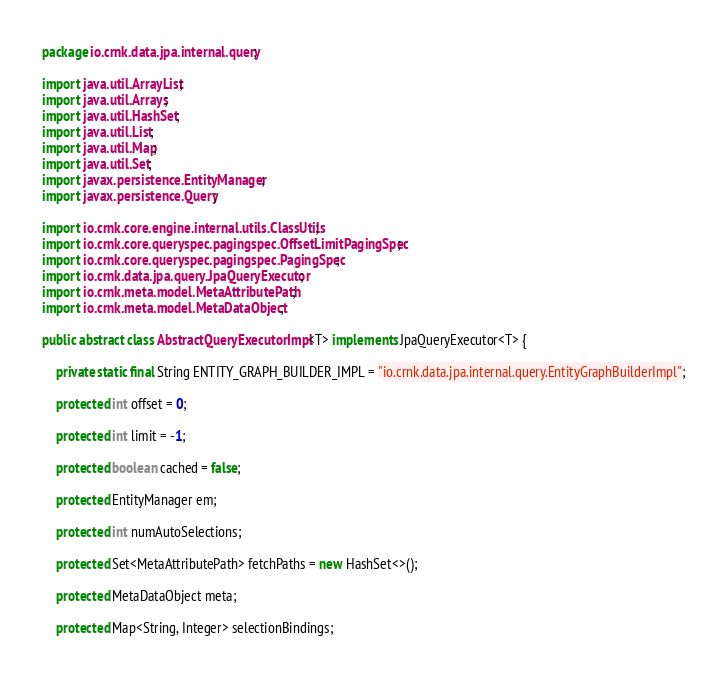<code> <loc_0><loc_0><loc_500><loc_500><_Java_>package io.crnk.data.jpa.internal.query;

import java.util.ArrayList;
import java.util.Arrays;
import java.util.HashSet;
import java.util.List;
import java.util.Map;
import java.util.Set;
import javax.persistence.EntityManager;
import javax.persistence.Query;

import io.crnk.core.engine.internal.utils.ClassUtils;
import io.crnk.core.queryspec.pagingspec.OffsetLimitPagingSpec;
import io.crnk.core.queryspec.pagingspec.PagingSpec;
import io.crnk.data.jpa.query.JpaQueryExecutor;
import io.crnk.meta.model.MetaAttributePath;
import io.crnk.meta.model.MetaDataObject;

public abstract class AbstractQueryExecutorImpl<T> implements JpaQueryExecutor<T> {

	private static final String ENTITY_GRAPH_BUILDER_IMPL = "io.crnk.data.jpa.internal.query.EntityGraphBuilderImpl";

	protected int offset = 0;

	protected int limit = -1;

	protected boolean cached = false;

	protected EntityManager em;

	protected int numAutoSelections;

	protected Set<MetaAttributePath> fetchPaths = new HashSet<>();

	protected MetaDataObject meta;

	protected Map<String, Integer> selectionBindings;
</code> 